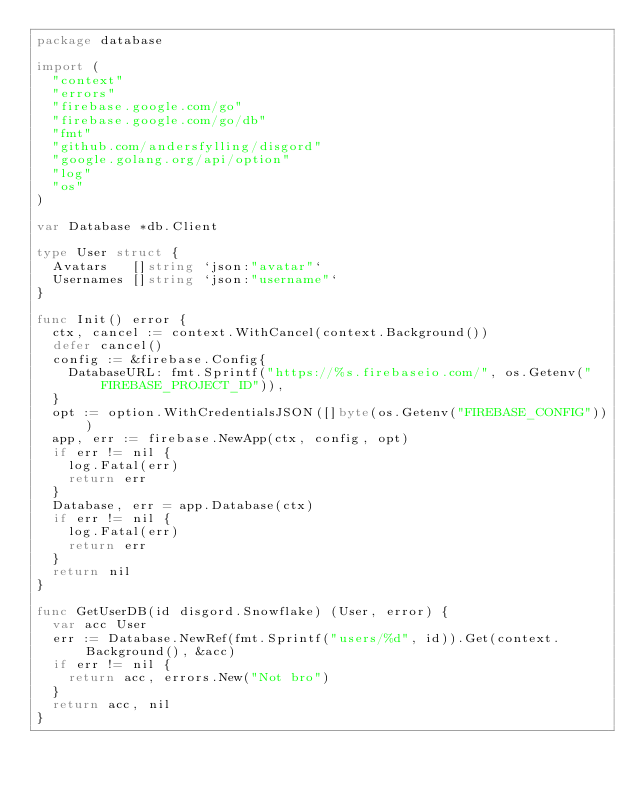<code> <loc_0><loc_0><loc_500><loc_500><_Go_>package database

import (
	"context"
	"errors"
	"firebase.google.com/go"
	"firebase.google.com/go/db"
	"fmt"
	"github.com/andersfylling/disgord"
	"google.golang.org/api/option"
	"log"
	"os"
)

var Database *db.Client

type User struct {
	Avatars   []string `json:"avatar"`
	Usernames []string `json:"username"`
}

func Init() error {
	ctx, cancel := context.WithCancel(context.Background())
	defer cancel()
	config := &firebase.Config{
		DatabaseURL: fmt.Sprintf("https://%s.firebaseio.com/", os.Getenv("FIREBASE_PROJECT_ID")),
	}
	opt := option.WithCredentialsJSON([]byte(os.Getenv("FIREBASE_CONFIG")))
	app, err := firebase.NewApp(ctx, config, opt)
	if err != nil {
		log.Fatal(err)
		return err
	}
	Database, err = app.Database(ctx)
	if err != nil {
		log.Fatal(err)
		return err
	}
	return nil
}

func GetUserDB(id disgord.Snowflake) (User, error) {
	var acc User
	err := Database.NewRef(fmt.Sprintf("users/%d", id)).Get(context.Background(), &acc)
	if err != nil {
		return acc, errors.New("Not bro")
	}
	return acc, nil
}
</code> 